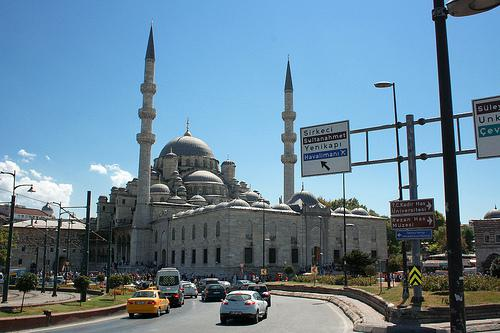Question: what is white?
Choices:
A. Snow.
B. Cotton.
C. Clouds.
D. Marshmallows.
Answer with the letter. Answer: C Question: where are clouds?
Choices:
A. Above us.
B. In the sky.
C. In the atmosphere.
D. Up high.
Answer with the letter. Answer: B Question: where are windows?
Choices:
A. On a home.
B. On a car.
C. On a truck.
D. On a building.
Answer with the letter. Answer: D Question: what is blue?
Choices:
A. Sky.
B. Ocean.
C. Sea.
D. River.
Answer with the letter. Answer: A Question: where was the photo taken?
Choices:
A. On the street.
B. At the train station.
C. In a car park.
D. In a garage.
Answer with the letter. Answer: A Question: when was the picture taken?
Choices:
A. Nighttime.
B. Daytime.
C. Evening.
D. Dawn.
Answer with the letter. Answer: B 